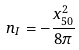Convert formula to latex. <formula><loc_0><loc_0><loc_500><loc_500>n _ { I } = - \frac { x _ { 5 0 } ^ { 2 } } { 8 \pi }</formula> 